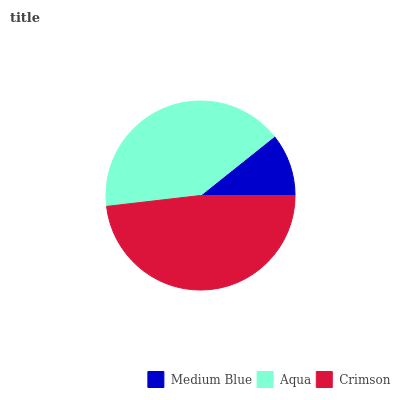Is Medium Blue the minimum?
Answer yes or no. Yes. Is Crimson the maximum?
Answer yes or no. Yes. Is Aqua the minimum?
Answer yes or no. No. Is Aqua the maximum?
Answer yes or no. No. Is Aqua greater than Medium Blue?
Answer yes or no. Yes. Is Medium Blue less than Aqua?
Answer yes or no. Yes. Is Medium Blue greater than Aqua?
Answer yes or no. No. Is Aqua less than Medium Blue?
Answer yes or no. No. Is Aqua the high median?
Answer yes or no. Yes. Is Aqua the low median?
Answer yes or no. Yes. Is Crimson the high median?
Answer yes or no. No. Is Crimson the low median?
Answer yes or no. No. 